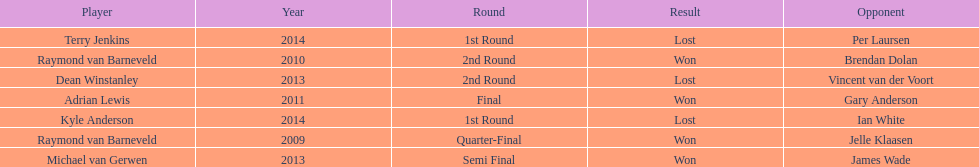Was the winner in 2014 terry jenkins or per laursen? Per Laursen. 